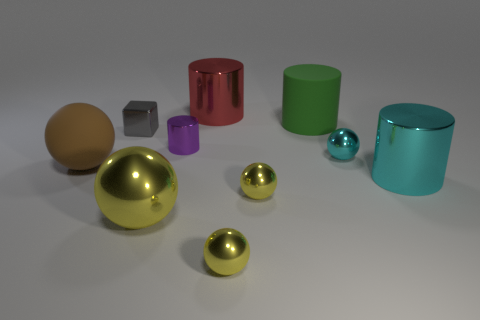How many yellow spheres must be subtracted to get 1 yellow spheres? 2 Subtract all purple blocks. How many yellow balls are left? 3 Subtract 3 balls. How many balls are left? 2 Subtract all cyan balls. How many balls are left? 4 Subtract all small shiny cylinders. How many cylinders are left? 3 Subtract all gray cylinders. Subtract all red blocks. How many cylinders are left? 4 Subtract all cubes. How many objects are left? 9 Add 5 brown matte balls. How many brown matte balls are left? 6 Add 8 large spheres. How many large spheres exist? 10 Subtract 0 green balls. How many objects are left? 10 